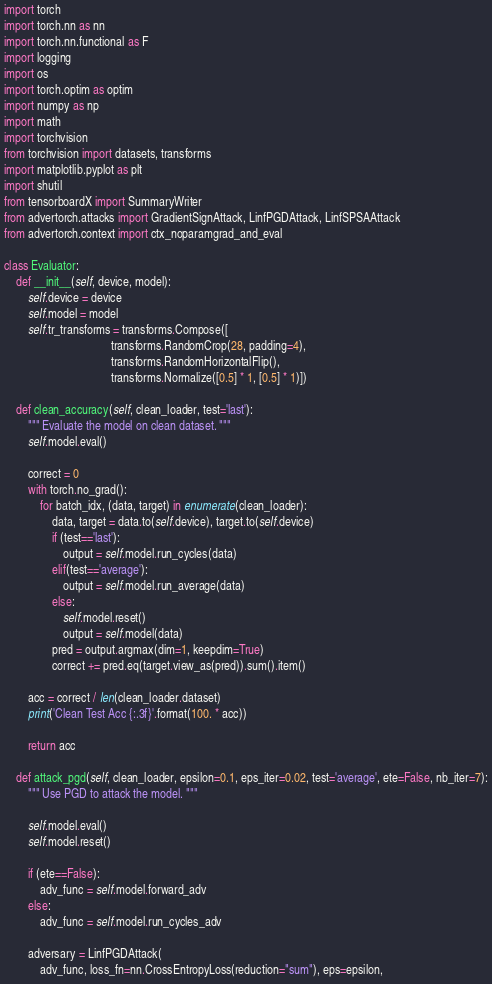Convert code to text. <code><loc_0><loc_0><loc_500><loc_500><_Python_>import torch
import torch.nn as nn
import torch.nn.functional as F
import logging
import os
import torch.optim as optim
import numpy as np
import math
import torchvision
from torchvision import datasets, transforms
import matplotlib.pyplot as plt
import shutil
from tensorboardX import SummaryWriter
from advertorch.attacks import GradientSignAttack, LinfPGDAttack, LinfSPSAAttack
from advertorch.context import ctx_noparamgrad_and_eval

class Evaluator:
    def __init__(self, device, model):
        self.device = device
        self.model = model
        self.tr_transforms = transforms.Compose([
                                    transforms.RandomCrop(28, padding=4),
									transforms.RandomHorizontalFlip(),
									transforms.Normalize([0.5] * 1, [0.5] * 1)])

    def clean_accuracy(self, clean_loader, test='last'):
        """ Evaluate the model on clean dataset. """
        self.model.eval()

        correct = 0
        with torch.no_grad():
            for batch_idx, (data, target) in enumerate(clean_loader):
                data, target = data.to(self.device), target.to(self.device)
                if (test=='last'):
                    output = self.model.run_cycles(data)
                elif(test=='average'):
                    output = self.model.run_average(data)
                else:
                    self.model.reset()
                    output = self.model(data)
                pred = output.argmax(dim=1, keepdim=True)
                correct += pred.eq(target.view_as(pred)).sum().item()

        acc = correct / len(clean_loader.dataset)
        print('Clean Test Acc {:.3f}'.format(100. * acc))

        return acc

    def attack_pgd(self, clean_loader, epsilon=0.1, eps_iter=0.02, test='average', ete=False, nb_iter=7):
        """ Use PGD to attack the model. """

        self.model.eval()
        self.model.reset()

        if (ete==False):
            adv_func = self.model.forward_adv
        else:
            adv_func = self.model.run_cycles_adv

        adversary = LinfPGDAttack(
            adv_func, loss_fn=nn.CrossEntropyLoss(reduction="sum"), eps=epsilon,</code> 